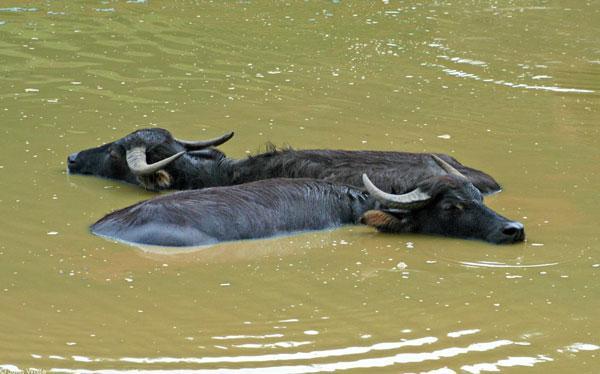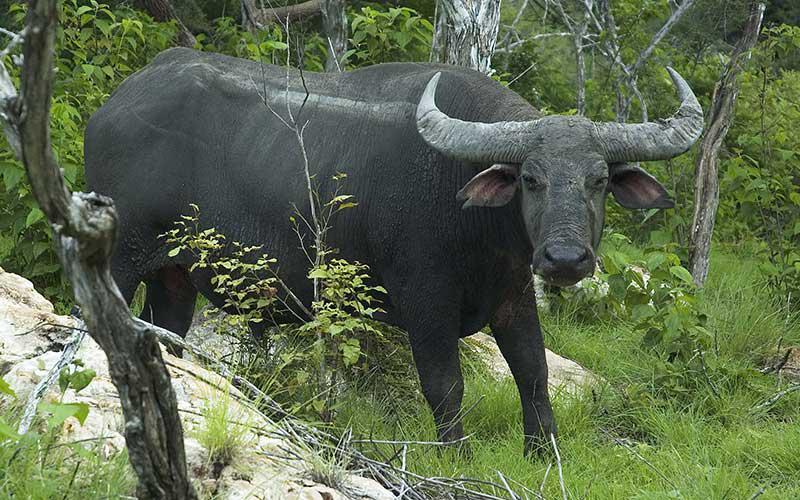The first image is the image on the left, the second image is the image on the right. For the images displayed, is the sentence "There are exactly three animals in total." factually correct? Answer yes or no. Yes. The first image is the image on the left, the second image is the image on the right. Given the left and right images, does the statement "There are exactly three animals with horns that are visible." hold true? Answer yes or no. Yes. 